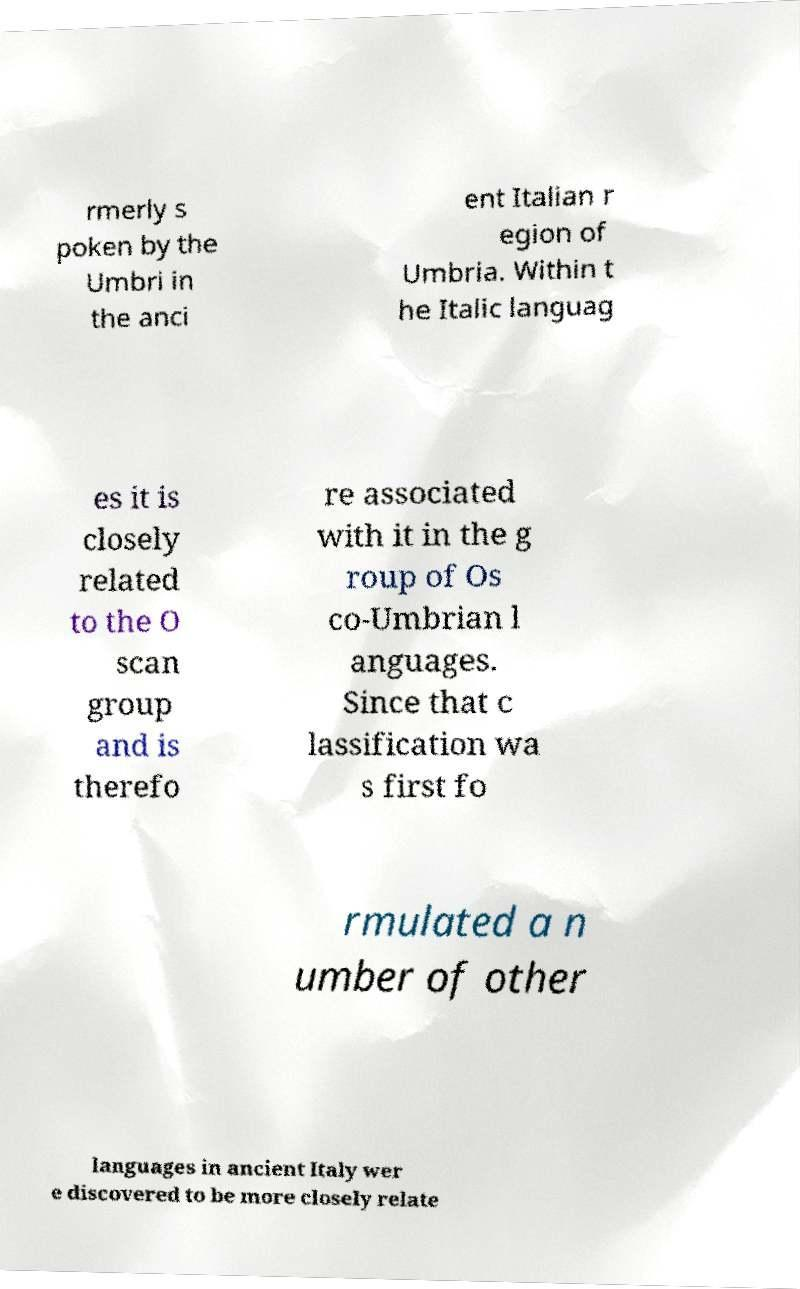I need the written content from this picture converted into text. Can you do that? rmerly s poken by the Umbri in the anci ent Italian r egion of Umbria. Within t he Italic languag es it is closely related to the O scan group and is therefo re associated with it in the g roup of Os co-Umbrian l anguages. Since that c lassification wa s first fo rmulated a n umber of other languages in ancient Italy wer e discovered to be more closely relate 